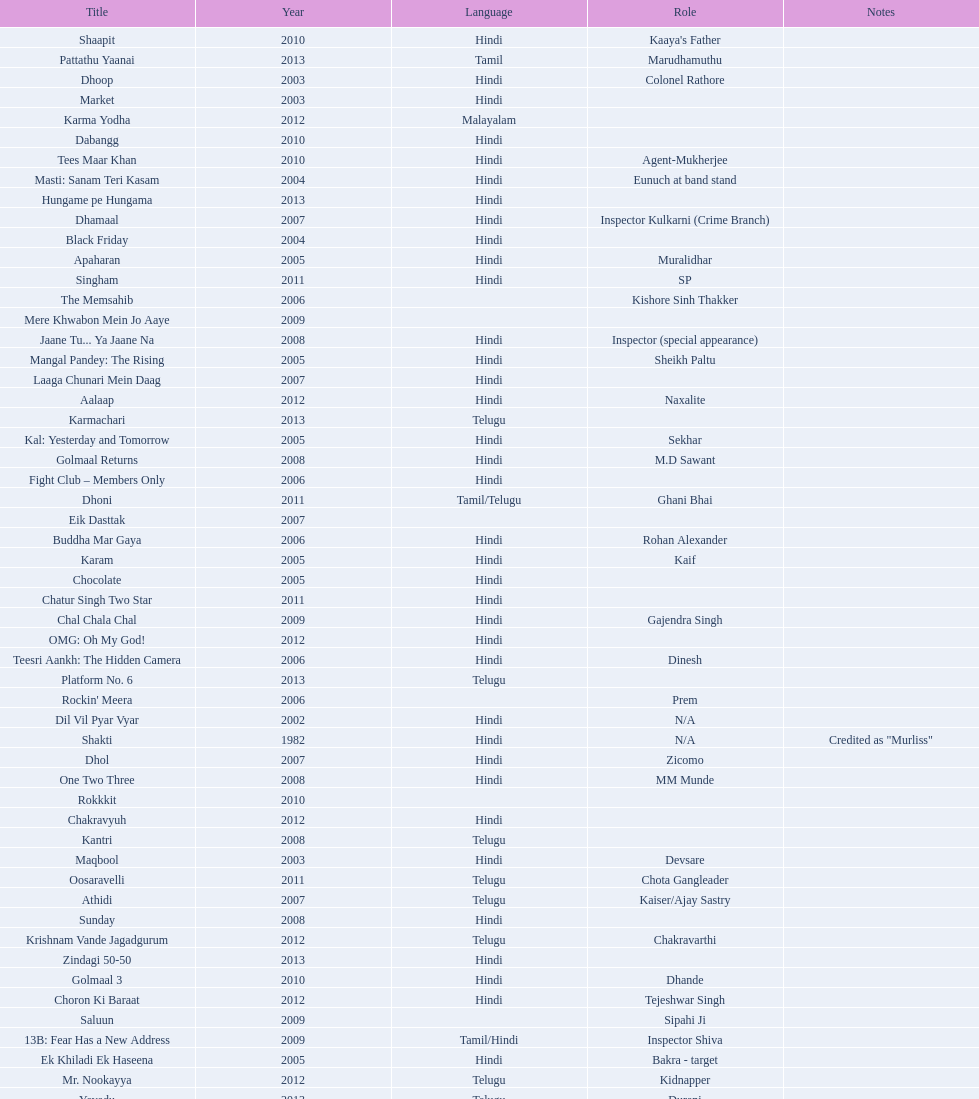How many roles has this actor had? 36. 